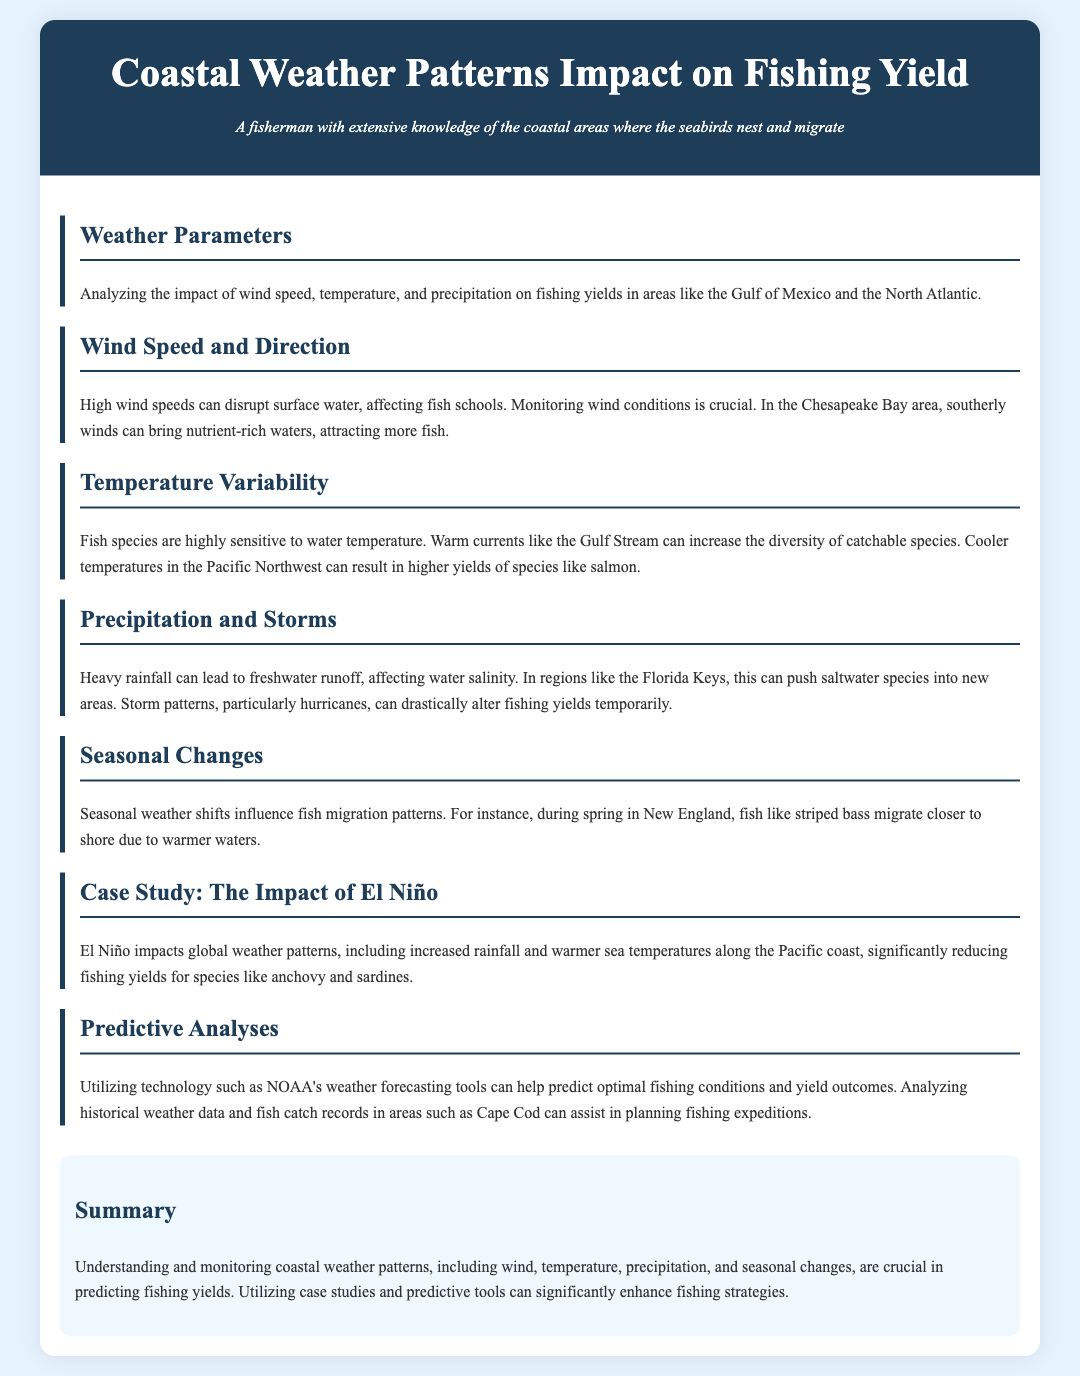What are the three weather parameters analyzed? The document mentions wind speed, temperature, and precipitation as key weather parameters impacting fishing yields.
Answer: wind speed, temperature, precipitation What effect do southerly winds have in the Chesapeake Bay area? The document states that southerly winds can bring nutrient-rich waters, attracting more fish in Chesapeake Bay.
Answer: attract more fish How do warm currents like the Gulf Stream affect fish diversity? According to the document, warm currents increase the diversity of catchable species due to their temperature sensitivity.
Answer: increase diversity What can heavy rainfall lead to in terms of water conditions? The document notes that heavy rainfall can lead to freshwater runoff, affecting water salinity.
Answer: affect water salinity During which season do striped bass migrate closer to shore in New England? The document specifies that striped bass migrate closer to shore during spring.
Answer: spring What global weather pattern significantly reduces fishing yields for anchovy and sardines? The document states that El Niño impacts global weather and reduces yields for these species.
Answer: El Niño What technology is used for predictive analyses in fishing? The document mentions NOAA's weather forecasting tools as a key technology for predictive analyses.
Answer: NOAA's weather forecasting tools What should fishermen monitor to predict fishing yields effectively? The document emphasizes monitoring coastal weather patterns as crucial for predicting fishing yields.
Answer: coastal weather patterns What is the case study focused on within the document? The case study in the document focuses on the impact of El Niño on fishing yields.
Answer: the impact of El Niño 